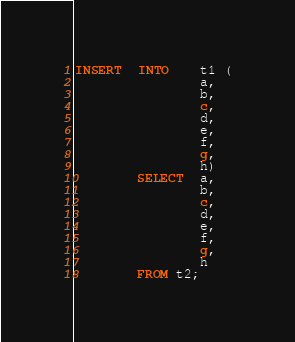<code> <loc_0><loc_0><loc_500><loc_500><_SQL_>INSERT  INTO    t1 (
                a,
                b,
                c,
                d,
                e,
                f,
                g,
                h)
        SELECT  a,
                b,
                c,
                d,
                e,
                f,
                g,
                h
        FROM t2;
</code> 